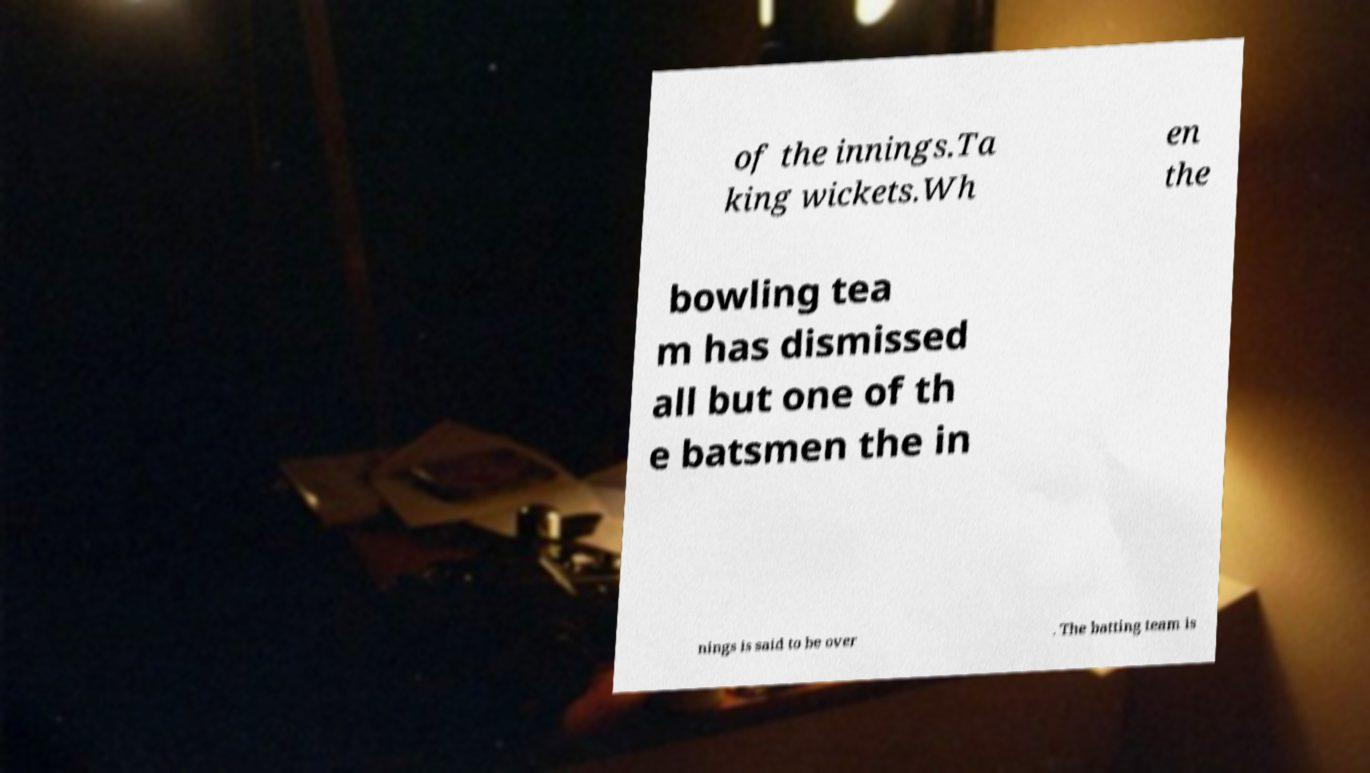Can you accurately transcribe the text from the provided image for me? of the innings.Ta king wickets.Wh en the bowling tea m has dismissed all but one of th e batsmen the in nings is said to be over . The batting team is 